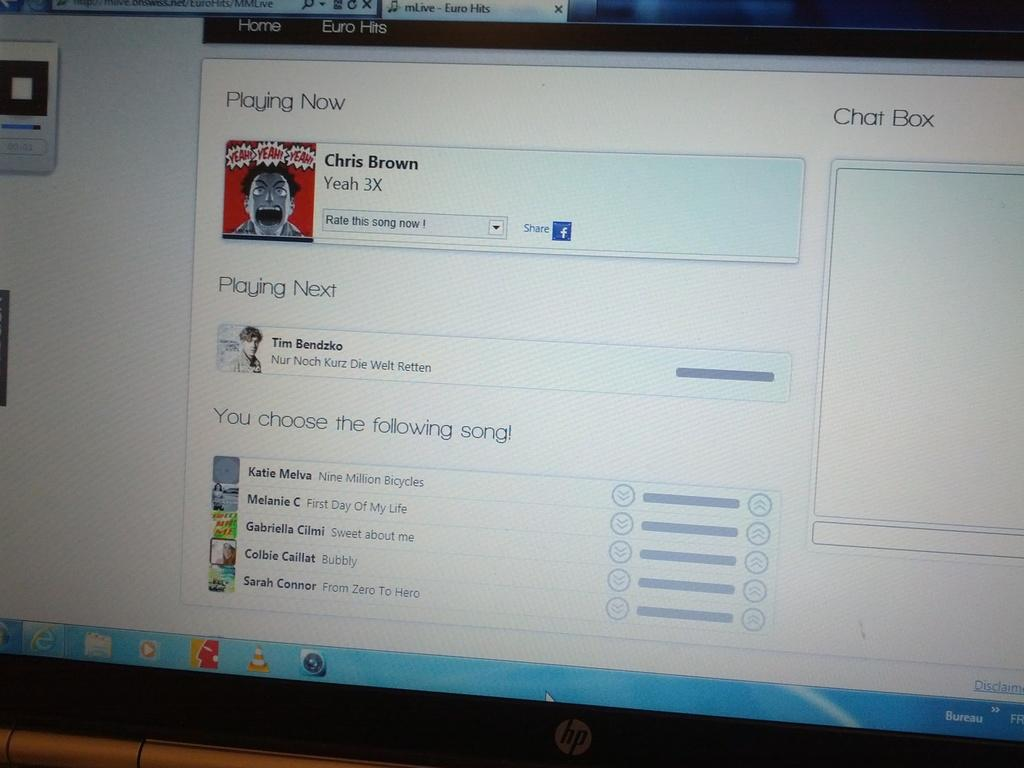What is the main object in the image? There is a monitor screen in the image. What can be seen on the monitor screen? The monitor screen displays text and contains dialogue boxes. Are there any visual elements on the monitor screen? Yes, animated pictures are present on the monitor screen. What else can be found on the monitor screen? Different icons are visible on the monitor screen. How does the monitor screen emit steam in the image? The monitor screen does not emit steam in the image; it displays text, dialogue boxes, animated pictures, and icons. Can you hear the monitor screen laughing in the image? The monitor screen does not make any sounds, such as laughter, in the image. 